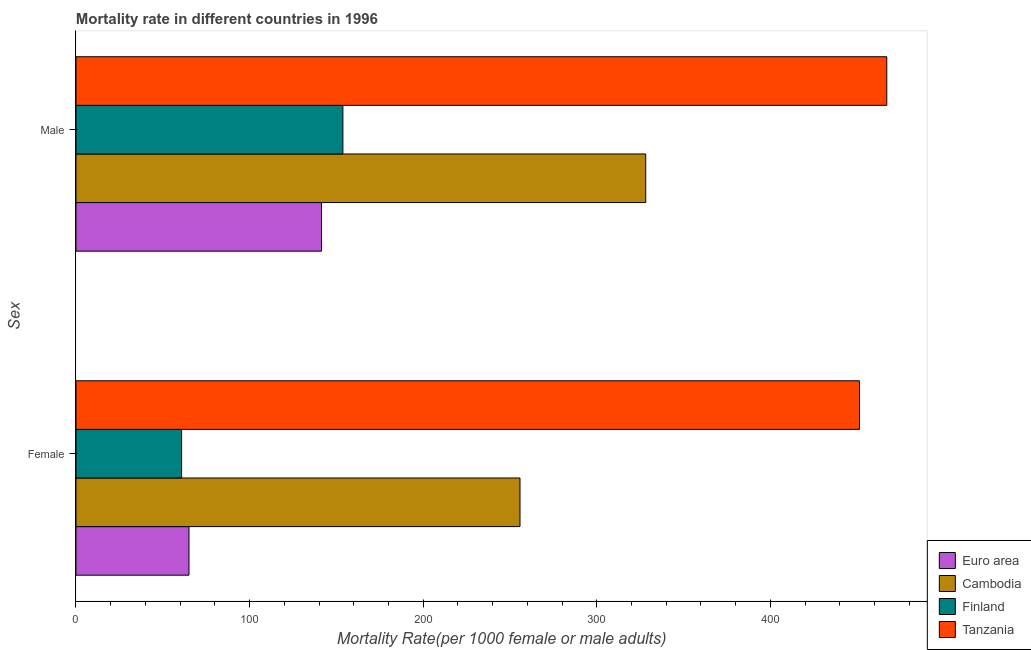How many groups of bars are there?
Provide a succinct answer. 2. Are the number of bars per tick equal to the number of legend labels?
Make the answer very short. Yes. Are the number of bars on each tick of the Y-axis equal?
Offer a terse response. Yes. How many bars are there on the 1st tick from the top?
Provide a succinct answer. 4. How many bars are there on the 2nd tick from the bottom?
Provide a short and direct response. 4. What is the female mortality rate in Cambodia?
Provide a succinct answer. 255.79. Across all countries, what is the maximum male mortality rate?
Your answer should be very brief. 467.09. Across all countries, what is the minimum male mortality rate?
Your answer should be compact. 141.47. In which country was the female mortality rate maximum?
Offer a very short reply. Tanzania. In which country was the male mortality rate minimum?
Your answer should be very brief. Euro area. What is the total male mortality rate in the graph?
Your answer should be compact. 1090.54. What is the difference between the male mortality rate in Finland and that in Euro area?
Your response must be concise. 12.29. What is the difference between the male mortality rate in Euro area and the female mortality rate in Cambodia?
Provide a short and direct response. -114.32. What is the average female mortality rate per country?
Your answer should be very brief. 208.27. What is the difference between the female mortality rate and male mortality rate in Cambodia?
Your response must be concise. -72.43. What is the ratio of the female mortality rate in Cambodia to that in Finland?
Offer a terse response. 4.2. What does the 1st bar from the top in Female represents?
Offer a terse response. Tanzania. How many bars are there?
Make the answer very short. 8. Are all the bars in the graph horizontal?
Offer a terse response. Yes. What is the difference between two consecutive major ticks on the X-axis?
Give a very brief answer. 100. Are the values on the major ticks of X-axis written in scientific E-notation?
Offer a very short reply. No. Does the graph contain any zero values?
Offer a terse response. No. How are the legend labels stacked?
Offer a terse response. Vertical. What is the title of the graph?
Offer a terse response. Mortality rate in different countries in 1996. Does "Zambia" appear as one of the legend labels in the graph?
Provide a short and direct response. No. What is the label or title of the X-axis?
Offer a terse response. Mortality Rate(per 1000 female or male adults). What is the label or title of the Y-axis?
Offer a terse response. Sex. What is the Mortality Rate(per 1000 female or male adults) of Euro area in Female?
Keep it short and to the point. 65.1. What is the Mortality Rate(per 1000 female or male adults) in Cambodia in Female?
Offer a very short reply. 255.79. What is the Mortality Rate(per 1000 female or male adults) in Finland in Female?
Your response must be concise. 60.83. What is the Mortality Rate(per 1000 female or male adults) in Tanzania in Female?
Offer a terse response. 451.37. What is the Mortality Rate(per 1000 female or male adults) in Euro area in Male?
Offer a terse response. 141.47. What is the Mortality Rate(per 1000 female or male adults) of Cambodia in Male?
Make the answer very short. 328.22. What is the Mortality Rate(per 1000 female or male adults) of Finland in Male?
Ensure brevity in your answer.  153.76. What is the Mortality Rate(per 1000 female or male adults) in Tanzania in Male?
Your answer should be very brief. 467.09. Across all Sex, what is the maximum Mortality Rate(per 1000 female or male adults) of Euro area?
Your answer should be very brief. 141.47. Across all Sex, what is the maximum Mortality Rate(per 1000 female or male adults) of Cambodia?
Ensure brevity in your answer.  328.22. Across all Sex, what is the maximum Mortality Rate(per 1000 female or male adults) in Finland?
Make the answer very short. 153.76. Across all Sex, what is the maximum Mortality Rate(per 1000 female or male adults) in Tanzania?
Your answer should be very brief. 467.09. Across all Sex, what is the minimum Mortality Rate(per 1000 female or male adults) of Euro area?
Keep it short and to the point. 65.1. Across all Sex, what is the minimum Mortality Rate(per 1000 female or male adults) in Cambodia?
Give a very brief answer. 255.79. Across all Sex, what is the minimum Mortality Rate(per 1000 female or male adults) of Finland?
Your response must be concise. 60.83. Across all Sex, what is the minimum Mortality Rate(per 1000 female or male adults) of Tanzania?
Ensure brevity in your answer.  451.37. What is the total Mortality Rate(per 1000 female or male adults) of Euro area in the graph?
Your response must be concise. 206.57. What is the total Mortality Rate(per 1000 female or male adults) of Cambodia in the graph?
Ensure brevity in your answer.  584.01. What is the total Mortality Rate(per 1000 female or male adults) in Finland in the graph?
Offer a very short reply. 214.59. What is the total Mortality Rate(per 1000 female or male adults) in Tanzania in the graph?
Your response must be concise. 918.46. What is the difference between the Mortality Rate(per 1000 female or male adults) in Euro area in Female and that in Male?
Keep it short and to the point. -76.38. What is the difference between the Mortality Rate(per 1000 female or male adults) in Cambodia in Female and that in Male?
Give a very brief answer. -72.43. What is the difference between the Mortality Rate(per 1000 female or male adults) in Finland in Female and that in Male?
Give a very brief answer. -92.92. What is the difference between the Mortality Rate(per 1000 female or male adults) in Tanzania in Female and that in Male?
Give a very brief answer. -15.72. What is the difference between the Mortality Rate(per 1000 female or male adults) in Euro area in Female and the Mortality Rate(per 1000 female or male adults) in Cambodia in Male?
Give a very brief answer. -263.13. What is the difference between the Mortality Rate(per 1000 female or male adults) of Euro area in Female and the Mortality Rate(per 1000 female or male adults) of Finland in Male?
Your answer should be very brief. -88.66. What is the difference between the Mortality Rate(per 1000 female or male adults) of Euro area in Female and the Mortality Rate(per 1000 female or male adults) of Tanzania in Male?
Ensure brevity in your answer.  -401.99. What is the difference between the Mortality Rate(per 1000 female or male adults) in Cambodia in Female and the Mortality Rate(per 1000 female or male adults) in Finland in Male?
Your answer should be very brief. 102.03. What is the difference between the Mortality Rate(per 1000 female or male adults) in Cambodia in Female and the Mortality Rate(per 1000 female or male adults) in Tanzania in Male?
Make the answer very short. -211.3. What is the difference between the Mortality Rate(per 1000 female or male adults) in Finland in Female and the Mortality Rate(per 1000 female or male adults) in Tanzania in Male?
Offer a very short reply. -406.26. What is the average Mortality Rate(per 1000 female or male adults) of Euro area per Sex?
Provide a short and direct response. 103.28. What is the average Mortality Rate(per 1000 female or male adults) of Cambodia per Sex?
Give a very brief answer. 292.01. What is the average Mortality Rate(per 1000 female or male adults) in Finland per Sex?
Provide a succinct answer. 107.3. What is the average Mortality Rate(per 1000 female or male adults) in Tanzania per Sex?
Offer a terse response. 459.23. What is the difference between the Mortality Rate(per 1000 female or male adults) in Euro area and Mortality Rate(per 1000 female or male adults) in Cambodia in Female?
Your answer should be compact. -190.69. What is the difference between the Mortality Rate(per 1000 female or male adults) in Euro area and Mortality Rate(per 1000 female or male adults) in Finland in Female?
Keep it short and to the point. 4.26. What is the difference between the Mortality Rate(per 1000 female or male adults) in Euro area and Mortality Rate(per 1000 female or male adults) in Tanzania in Female?
Your response must be concise. -386.27. What is the difference between the Mortality Rate(per 1000 female or male adults) of Cambodia and Mortality Rate(per 1000 female or male adults) of Finland in Female?
Your answer should be very brief. 194.96. What is the difference between the Mortality Rate(per 1000 female or male adults) of Cambodia and Mortality Rate(per 1000 female or male adults) of Tanzania in Female?
Your answer should be very brief. -195.58. What is the difference between the Mortality Rate(per 1000 female or male adults) in Finland and Mortality Rate(per 1000 female or male adults) in Tanzania in Female?
Ensure brevity in your answer.  -390.54. What is the difference between the Mortality Rate(per 1000 female or male adults) in Euro area and Mortality Rate(per 1000 female or male adults) in Cambodia in Male?
Ensure brevity in your answer.  -186.75. What is the difference between the Mortality Rate(per 1000 female or male adults) of Euro area and Mortality Rate(per 1000 female or male adults) of Finland in Male?
Provide a short and direct response. -12.29. What is the difference between the Mortality Rate(per 1000 female or male adults) of Euro area and Mortality Rate(per 1000 female or male adults) of Tanzania in Male?
Provide a succinct answer. -325.62. What is the difference between the Mortality Rate(per 1000 female or male adults) in Cambodia and Mortality Rate(per 1000 female or male adults) in Finland in Male?
Keep it short and to the point. 174.47. What is the difference between the Mortality Rate(per 1000 female or male adults) of Cambodia and Mortality Rate(per 1000 female or male adults) of Tanzania in Male?
Offer a very short reply. -138.87. What is the difference between the Mortality Rate(per 1000 female or male adults) in Finland and Mortality Rate(per 1000 female or male adults) in Tanzania in Male?
Make the answer very short. -313.33. What is the ratio of the Mortality Rate(per 1000 female or male adults) in Euro area in Female to that in Male?
Keep it short and to the point. 0.46. What is the ratio of the Mortality Rate(per 1000 female or male adults) of Cambodia in Female to that in Male?
Provide a succinct answer. 0.78. What is the ratio of the Mortality Rate(per 1000 female or male adults) in Finland in Female to that in Male?
Keep it short and to the point. 0.4. What is the ratio of the Mortality Rate(per 1000 female or male adults) of Tanzania in Female to that in Male?
Provide a succinct answer. 0.97. What is the difference between the highest and the second highest Mortality Rate(per 1000 female or male adults) in Euro area?
Make the answer very short. 76.38. What is the difference between the highest and the second highest Mortality Rate(per 1000 female or male adults) in Cambodia?
Give a very brief answer. 72.43. What is the difference between the highest and the second highest Mortality Rate(per 1000 female or male adults) of Finland?
Ensure brevity in your answer.  92.92. What is the difference between the highest and the second highest Mortality Rate(per 1000 female or male adults) in Tanzania?
Give a very brief answer. 15.72. What is the difference between the highest and the lowest Mortality Rate(per 1000 female or male adults) of Euro area?
Keep it short and to the point. 76.38. What is the difference between the highest and the lowest Mortality Rate(per 1000 female or male adults) of Cambodia?
Provide a short and direct response. 72.43. What is the difference between the highest and the lowest Mortality Rate(per 1000 female or male adults) of Finland?
Your answer should be compact. 92.92. What is the difference between the highest and the lowest Mortality Rate(per 1000 female or male adults) in Tanzania?
Offer a terse response. 15.72. 